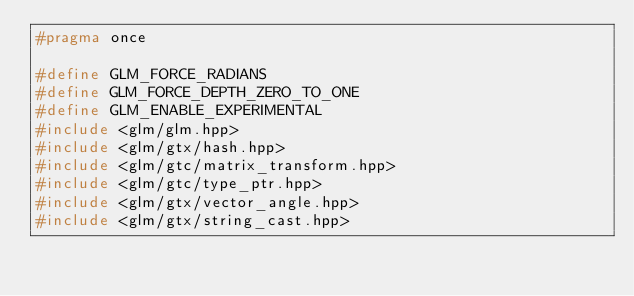<code> <loc_0><loc_0><loc_500><loc_500><_C_>#pragma once

#define GLM_FORCE_RADIANS
#define GLM_FORCE_DEPTH_ZERO_TO_ONE
#define GLM_ENABLE_EXPERIMENTAL
#include <glm/glm.hpp>
#include <glm/gtx/hash.hpp>
#include <glm/gtc/matrix_transform.hpp>
#include <glm/gtc/type_ptr.hpp>
#include <glm/gtx/vector_angle.hpp>
#include <glm/gtx/string_cast.hpp></code> 